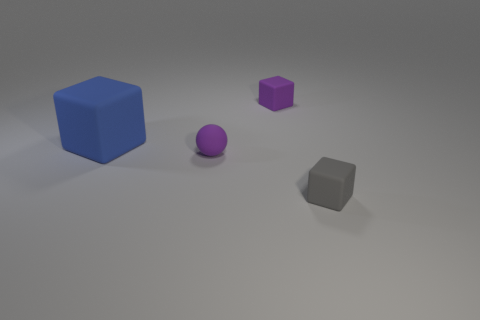Subtract all brown spheres. Subtract all red cylinders. How many spheres are left? 1 Add 1 small brown cylinders. How many objects exist? 5 Subtract all cubes. How many objects are left? 1 Add 1 big matte cubes. How many big matte cubes exist? 2 Subtract 0 brown spheres. How many objects are left? 4 Subtract all matte blocks. Subtract all small blue metal cylinders. How many objects are left? 1 Add 2 gray objects. How many gray objects are left? 3 